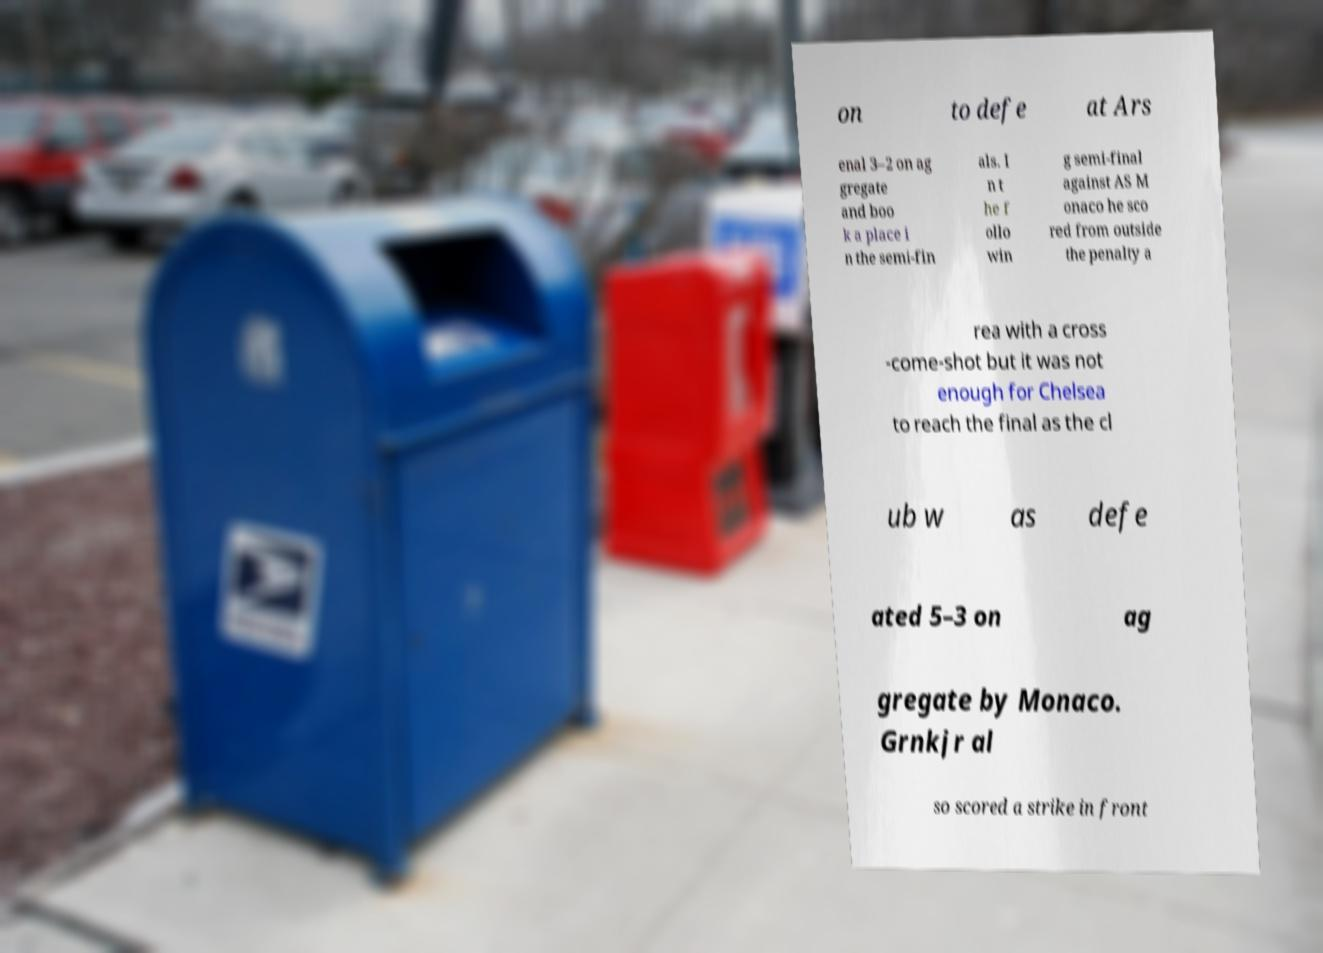What messages or text are displayed in this image? I need them in a readable, typed format. on to defe at Ars enal 3–2 on ag gregate and boo k a place i n the semi-fin als. I n t he f ollo win g semi-final against AS M onaco he sco red from outside the penalty a rea with a cross -come-shot but it was not enough for Chelsea to reach the final as the cl ub w as defe ated 5–3 on ag gregate by Monaco. Grnkjr al so scored a strike in front 